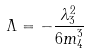Convert formula to latex. <formula><loc_0><loc_0><loc_500><loc_500>\Lambda = - \frac { \lambda _ { 3 } ^ { 2 } } { 6 m _ { 4 } ^ { 3 } }</formula> 